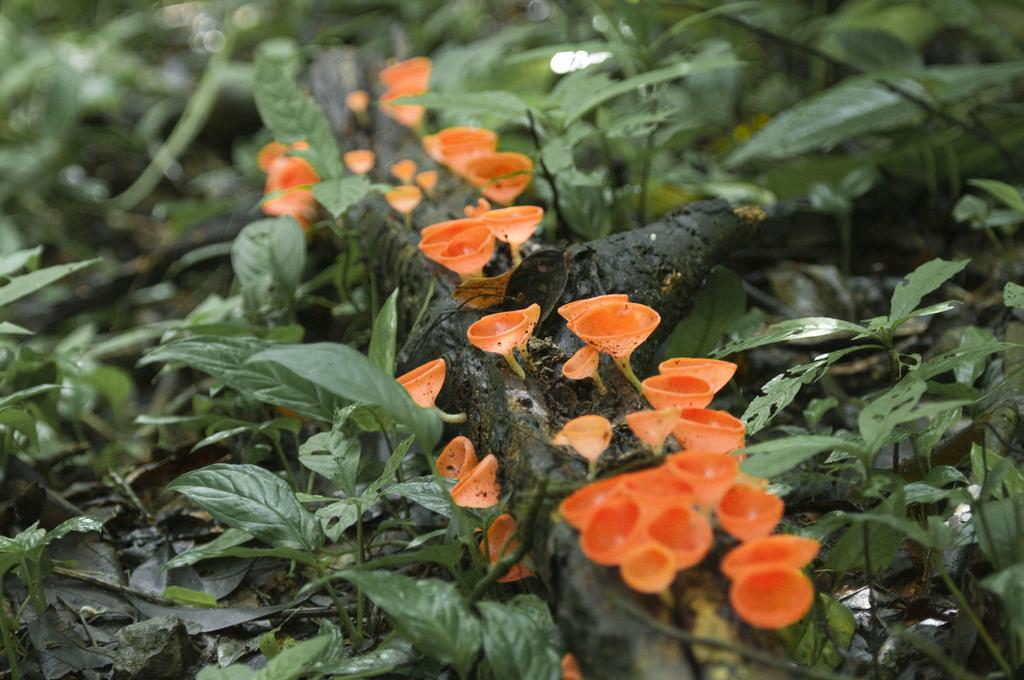What type of living organisms are present in the image? There are plants in the image. What part of the plants can be seen in the image? The plants have leaves and stems. Are there any additional features on the plants? Yes, there are flowers on the stems. What is the color of the flowers? The flowers are orange in color. How does the moon control the rainstorm in the image? There is no moon or rainstorm present in the image; it features plants with leaves, stems, and orange flowers. 